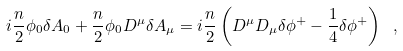<formula> <loc_0><loc_0><loc_500><loc_500>i \frac { n } { 2 } \phi _ { 0 } \delta A _ { 0 } + \frac { n } { 2 } \phi _ { 0 } D ^ { \mu } \delta A _ { \mu } = i \frac { n } { 2 } \left ( D ^ { \mu } D _ { \mu } \delta \phi ^ { + } - \frac { 1 } { 4 } \delta \phi ^ { + } \right ) \ ,</formula> 